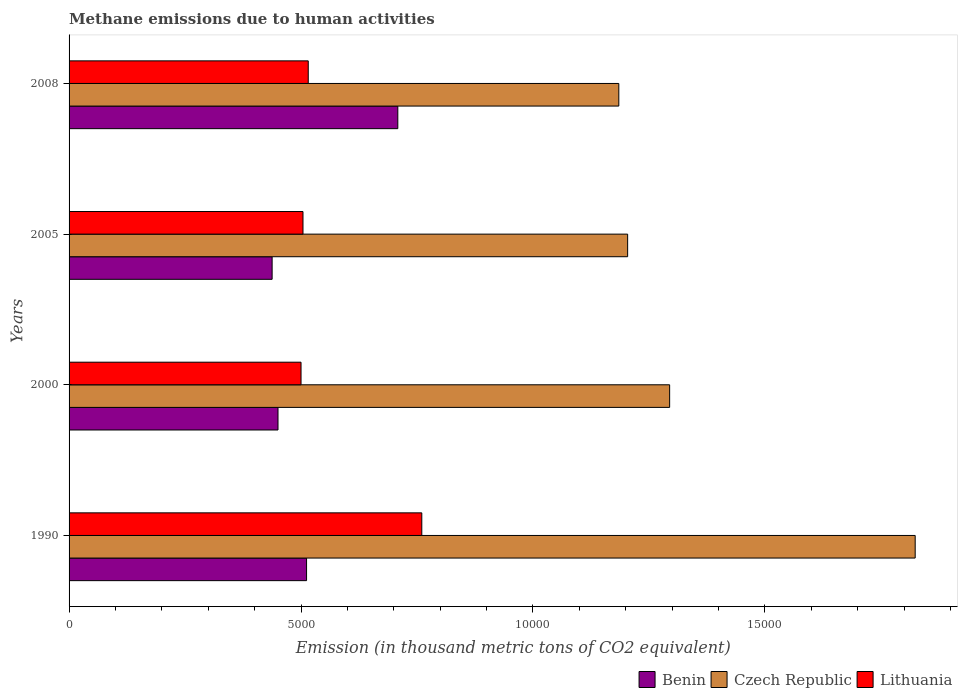How many bars are there on the 3rd tick from the top?
Your response must be concise. 3. What is the label of the 3rd group of bars from the top?
Your answer should be very brief. 2000. What is the amount of methane emitted in Benin in 2008?
Keep it short and to the point. 7086.6. Across all years, what is the maximum amount of methane emitted in Benin?
Your answer should be very brief. 7086.6. Across all years, what is the minimum amount of methane emitted in Czech Republic?
Your answer should be compact. 1.19e+04. In which year was the amount of methane emitted in Lithuania maximum?
Keep it short and to the point. 1990. What is the total amount of methane emitted in Czech Republic in the graph?
Offer a very short reply. 5.51e+04. What is the difference between the amount of methane emitted in Benin in 2000 and that in 2008?
Provide a succinct answer. -2582.8. What is the difference between the amount of methane emitted in Lithuania in 2005 and the amount of methane emitted in Czech Republic in 2008?
Provide a short and direct response. -6808.2. What is the average amount of methane emitted in Benin per year?
Keep it short and to the point. 5271.8. In the year 2000, what is the difference between the amount of methane emitted in Benin and amount of methane emitted in Lithuania?
Ensure brevity in your answer.  -496.4. What is the ratio of the amount of methane emitted in Benin in 2005 to that in 2008?
Give a very brief answer. 0.62. Is the amount of methane emitted in Benin in 2000 less than that in 2008?
Provide a succinct answer. Yes. What is the difference between the highest and the second highest amount of methane emitted in Benin?
Your answer should be very brief. 1967.1. What is the difference between the highest and the lowest amount of methane emitted in Czech Republic?
Your answer should be compact. 6388.9. In how many years, is the amount of methane emitted in Lithuania greater than the average amount of methane emitted in Lithuania taken over all years?
Provide a succinct answer. 1. Is the sum of the amount of methane emitted in Benin in 1990 and 2008 greater than the maximum amount of methane emitted in Lithuania across all years?
Give a very brief answer. Yes. What does the 2nd bar from the top in 1990 represents?
Offer a very short reply. Czech Republic. What does the 3rd bar from the bottom in 2000 represents?
Offer a very short reply. Lithuania. Is it the case that in every year, the sum of the amount of methane emitted in Czech Republic and amount of methane emitted in Benin is greater than the amount of methane emitted in Lithuania?
Make the answer very short. Yes. How many years are there in the graph?
Your answer should be compact. 4. What is the difference between two consecutive major ticks on the X-axis?
Offer a very short reply. 5000. Does the graph contain any zero values?
Ensure brevity in your answer.  No. Does the graph contain grids?
Keep it short and to the point. No. Where does the legend appear in the graph?
Make the answer very short. Bottom right. How many legend labels are there?
Your response must be concise. 3. How are the legend labels stacked?
Your response must be concise. Horizontal. What is the title of the graph?
Give a very brief answer. Methane emissions due to human activities. Does "Eritrea" appear as one of the legend labels in the graph?
Your response must be concise. No. What is the label or title of the X-axis?
Your response must be concise. Emission (in thousand metric tons of CO2 equivalent). What is the label or title of the Y-axis?
Give a very brief answer. Years. What is the Emission (in thousand metric tons of CO2 equivalent) of Benin in 1990?
Give a very brief answer. 5119.5. What is the Emission (in thousand metric tons of CO2 equivalent) of Czech Republic in 1990?
Your answer should be very brief. 1.82e+04. What is the Emission (in thousand metric tons of CO2 equivalent) of Lithuania in 1990?
Make the answer very short. 7603.6. What is the Emission (in thousand metric tons of CO2 equivalent) in Benin in 2000?
Offer a very short reply. 4503.8. What is the Emission (in thousand metric tons of CO2 equivalent) in Czech Republic in 2000?
Provide a short and direct response. 1.29e+04. What is the Emission (in thousand metric tons of CO2 equivalent) in Lithuania in 2000?
Give a very brief answer. 5000.2. What is the Emission (in thousand metric tons of CO2 equivalent) in Benin in 2005?
Give a very brief answer. 4377.3. What is the Emission (in thousand metric tons of CO2 equivalent) in Czech Republic in 2005?
Your answer should be compact. 1.20e+04. What is the Emission (in thousand metric tons of CO2 equivalent) in Lithuania in 2005?
Provide a short and direct response. 5042.2. What is the Emission (in thousand metric tons of CO2 equivalent) in Benin in 2008?
Keep it short and to the point. 7086.6. What is the Emission (in thousand metric tons of CO2 equivalent) in Czech Republic in 2008?
Your answer should be very brief. 1.19e+04. What is the Emission (in thousand metric tons of CO2 equivalent) of Lithuania in 2008?
Ensure brevity in your answer.  5155.8. Across all years, what is the maximum Emission (in thousand metric tons of CO2 equivalent) in Benin?
Your answer should be very brief. 7086.6. Across all years, what is the maximum Emission (in thousand metric tons of CO2 equivalent) in Czech Republic?
Keep it short and to the point. 1.82e+04. Across all years, what is the maximum Emission (in thousand metric tons of CO2 equivalent) in Lithuania?
Give a very brief answer. 7603.6. Across all years, what is the minimum Emission (in thousand metric tons of CO2 equivalent) in Benin?
Your response must be concise. 4377.3. Across all years, what is the minimum Emission (in thousand metric tons of CO2 equivalent) in Czech Republic?
Provide a succinct answer. 1.19e+04. Across all years, what is the minimum Emission (in thousand metric tons of CO2 equivalent) in Lithuania?
Your answer should be very brief. 5000.2. What is the total Emission (in thousand metric tons of CO2 equivalent) in Benin in the graph?
Offer a very short reply. 2.11e+04. What is the total Emission (in thousand metric tons of CO2 equivalent) in Czech Republic in the graph?
Your answer should be very brief. 5.51e+04. What is the total Emission (in thousand metric tons of CO2 equivalent) in Lithuania in the graph?
Your answer should be compact. 2.28e+04. What is the difference between the Emission (in thousand metric tons of CO2 equivalent) of Benin in 1990 and that in 2000?
Keep it short and to the point. 615.7. What is the difference between the Emission (in thousand metric tons of CO2 equivalent) of Czech Republic in 1990 and that in 2000?
Give a very brief answer. 5293.1. What is the difference between the Emission (in thousand metric tons of CO2 equivalent) in Lithuania in 1990 and that in 2000?
Provide a succinct answer. 2603.4. What is the difference between the Emission (in thousand metric tons of CO2 equivalent) of Benin in 1990 and that in 2005?
Keep it short and to the point. 742.2. What is the difference between the Emission (in thousand metric tons of CO2 equivalent) in Czech Republic in 1990 and that in 2005?
Provide a succinct answer. 6198.5. What is the difference between the Emission (in thousand metric tons of CO2 equivalent) in Lithuania in 1990 and that in 2005?
Your answer should be very brief. 2561.4. What is the difference between the Emission (in thousand metric tons of CO2 equivalent) in Benin in 1990 and that in 2008?
Your answer should be very brief. -1967.1. What is the difference between the Emission (in thousand metric tons of CO2 equivalent) of Czech Republic in 1990 and that in 2008?
Give a very brief answer. 6388.9. What is the difference between the Emission (in thousand metric tons of CO2 equivalent) of Lithuania in 1990 and that in 2008?
Your answer should be compact. 2447.8. What is the difference between the Emission (in thousand metric tons of CO2 equivalent) in Benin in 2000 and that in 2005?
Your response must be concise. 126.5. What is the difference between the Emission (in thousand metric tons of CO2 equivalent) in Czech Republic in 2000 and that in 2005?
Offer a terse response. 905.4. What is the difference between the Emission (in thousand metric tons of CO2 equivalent) in Lithuania in 2000 and that in 2005?
Keep it short and to the point. -42. What is the difference between the Emission (in thousand metric tons of CO2 equivalent) in Benin in 2000 and that in 2008?
Keep it short and to the point. -2582.8. What is the difference between the Emission (in thousand metric tons of CO2 equivalent) of Czech Republic in 2000 and that in 2008?
Ensure brevity in your answer.  1095.8. What is the difference between the Emission (in thousand metric tons of CO2 equivalent) in Lithuania in 2000 and that in 2008?
Your answer should be compact. -155.6. What is the difference between the Emission (in thousand metric tons of CO2 equivalent) in Benin in 2005 and that in 2008?
Your answer should be very brief. -2709.3. What is the difference between the Emission (in thousand metric tons of CO2 equivalent) in Czech Republic in 2005 and that in 2008?
Your answer should be very brief. 190.4. What is the difference between the Emission (in thousand metric tons of CO2 equivalent) of Lithuania in 2005 and that in 2008?
Provide a succinct answer. -113.6. What is the difference between the Emission (in thousand metric tons of CO2 equivalent) in Benin in 1990 and the Emission (in thousand metric tons of CO2 equivalent) in Czech Republic in 2000?
Offer a terse response. -7826.7. What is the difference between the Emission (in thousand metric tons of CO2 equivalent) of Benin in 1990 and the Emission (in thousand metric tons of CO2 equivalent) of Lithuania in 2000?
Your response must be concise. 119.3. What is the difference between the Emission (in thousand metric tons of CO2 equivalent) in Czech Republic in 1990 and the Emission (in thousand metric tons of CO2 equivalent) in Lithuania in 2000?
Your answer should be very brief. 1.32e+04. What is the difference between the Emission (in thousand metric tons of CO2 equivalent) in Benin in 1990 and the Emission (in thousand metric tons of CO2 equivalent) in Czech Republic in 2005?
Offer a very short reply. -6921.3. What is the difference between the Emission (in thousand metric tons of CO2 equivalent) in Benin in 1990 and the Emission (in thousand metric tons of CO2 equivalent) in Lithuania in 2005?
Offer a terse response. 77.3. What is the difference between the Emission (in thousand metric tons of CO2 equivalent) in Czech Republic in 1990 and the Emission (in thousand metric tons of CO2 equivalent) in Lithuania in 2005?
Offer a terse response. 1.32e+04. What is the difference between the Emission (in thousand metric tons of CO2 equivalent) of Benin in 1990 and the Emission (in thousand metric tons of CO2 equivalent) of Czech Republic in 2008?
Keep it short and to the point. -6730.9. What is the difference between the Emission (in thousand metric tons of CO2 equivalent) in Benin in 1990 and the Emission (in thousand metric tons of CO2 equivalent) in Lithuania in 2008?
Your response must be concise. -36.3. What is the difference between the Emission (in thousand metric tons of CO2 equivalent) in Czech Republic in 1990 and the Emission (in thousand metric tons of CO2 equivalent) in Lithuania in 2008?
Your answer should be compact. 1.31e+04. What is the difference between the Emission (in thousand metric tons of CO2 equivalent) in Benin in 2000 and the Emission (in thousand metric tons of CO2 equivalent) in Czech Republic in 2005?
Give a very brief answer. -7537. What is the difference between the Emission (in thousand metric tons of CO2 equivalent) of Benin in 2000 and the Emission (in thousand metric tons of CO2 equivalent) of Lithuania in 2005?
Give a very brief answer. -538.4. What is the difference between the Emission (in thousand metric tons of CO2 equivalent) of Czech Republic in 2000 and the Emission (in thousand metric tons of CO2 equivalent) of Lithuania in 2005?
Provide a succinct answer. 7904. What is the difference between the Emission (in thousand metric tons of CO2 equivalent) of Benin in 2000 and the Emission (in thousand metric tons of CO2 equivalent) of Czech Republic in 2008?
Offer a very short reply. -7346.6. What is the difference between the Emission (in thousand metric tons of CO2 equivalent) in Benin in 2000 and the Emission (in thousand metric tons of CO2 equivalent) in Lithuania in 2008?
Your answer should be compact. -652. What is the difference between the Emission (in thousand metric tons of CO2 equivalent) in Czech Republic in 2000 and the Emission (in thousand metric tons of CO2 equivalent) in Lithuania in 2008?
Offer a very short reply. 7790.4. What is the difference between the Emission (in thousand metric tons of CO2 equivalent) of Benin in 2005 and the Emission (in thousand metric tons of CO2 equivalent) of Czech Republic in 2008?
Your response must be concise. -7473.1. What is the difference between the Emission (in thousand metric tons of CO2 equivalent) in Benin in 2005 and the Emission (in thousand metric tons of CO2 equivalent) in Lithuania in 2008?
Offer a terse response. -778.5. What is the difference between the Emission (in thousand metric tons of CO2 equivalent) in Czech Republic in 2005 and the Emission (in thousand metric tons of CO2 equivalent) in Lithuania in 2008?
Provide a succinct answer. 6885. What is the average Emission (in thousand metric tons of CO2 equivalent) in Benin per year?
Offer a very short reply. 5271.8. What is the average Emission (in thousand metric tons of CO2 equivalent) in Czech Republic per year?
Offer a very short reply. 1.38e+04. What is the average Emission (in thousand metric tons of CO2 equivalent) of Lithuania per year?
Ensure brevity in your answer.  5700.45. In the year 1990, what is the difference between the Emission (in thousand metric tons of CO2 equivalent) in Benin and Emission (in thousand metric tons of CO2 equivalent) in Czech Republic?
Provide a succinct answer. -1.31e+04. In the year 1990, what is the difference between the Emission (in thousand metric tons of CO2 equivalent) of Benin and Emission (in thousand metric tons of CO2 equivalent) of Lithuania?
Provide a succinct answer. -2484.1. In the year 1990, what is the difference between the Emission (in thousand metric tons of CO2 equivalent) of Czech Republic and Emission (in thousand metric tons of CO2 equivalent) of Lithuania?
Your answer should be compact. 1.06e+04. In the year 2000, what is the difference between the Emission (in thousand metric tons of CO2 equivalent) in Benin and Emission (in thousand metric tons of CO2 equivalent) in Czech Republic?
Your answer should be compact. -8442.4. In the year 2000, what is the difference between the Emission (in thousand metric tons of CO2 equivalent) of Benin and Emission (in thousand metric tons of CO2 equivalent) of Lithuania?
Make the answer very short. -496.4. In the year 2000, what is the difference between the Emission (in thousand metric tons of CO2 equivalent) in Czech Republic and Emission (in thousand metric tons of CO2 equivalent) in Lithuania?
Make the answer very short. 7946. In the year 2005, what is the difference between the Emission (in thousand metric tons of CO2 equivalent) of Benin and Emission (in thousand metric tons of CO2 equivalent) of Czech Republic?
Provide a succinct answer. -7663.5. In the year 2005, what is the difference between the Emission (in thousand metric tons of CO2 equivalent) in Benin and Emission (in thousand metric tons of CO2 equivalent) in Lithuania?
Give a very brief answer. -664.9. In the year 2005, what is the difference between the Emission (in thousand metric tons of CO2 equivalent) in Czech Republic and Emission (in thousand metric tons of CO2 equivalent) in Lithuania?
Give a very brief answer. 6998.6. In the year 2008, what is the difference between the Emission (in thousand metric tons of CO2 equivalent) in Benin and Emission (in thousand metric tons of CO2 equivalent) in Czech Republic?
Your answer should be very brief. -4763.8. In the year 2008, what is the difference between the Emission (in thousand metric tons of CO2 equivalent) of Benin and Emission (in thousand metric tons of CO2 equivalent) of Lithuania?
Provide a succinct answer. 1930.8. In the year 2008, what is the difference between the Emission (in thousand metric tons of CO2 equivalent) of Czech Republic and Emission (in thousand metric tons of CO2 equivalent) of Lithuania?
Offer a very short reply. 6694.6. What is the ratio of the Emission (in thousand metric tons of CO2 equivalent) in Benin in 1990 to that in 2000?
Give a very brief answer. 1.14. What is the ratio of the Emission (in thousand metric tons of CO2 equivalent) in Czech Republic in 1990 to that in 2000?
Your response must be concise. 1.41. What is the ratio of the Emission (in thousand metric tons of CO2 equivalent) of Lithuania in 1990 to that in 2000?
Provide a succinct answer. 1.52. What is the ratio of the Emission (in thousand metric tons of CO2 equivalent) in Benin in 1990 to that in 2005?
Make the answer very short. 1.17. What is the ratio of the Emission (in thousand metric tons of CO2 equivalent) in Czech Republic in 1990 to that in 2005?
Your answer should be very brief. 1.51. What is the ratio of the Emission (in thousand metric tons of CO2 equivalent) of Lithuania in 1990 to that in 2005?
Provide a short and direct response. 1.51. What is the ratio of the Emission (in thousand metric tons of CO2 equivalent) in Benin in 1990 to that in 2008?
Make the answer very short. 0.72. What is the ratio of the Emission (in thousand metric tons of CO2 equivalent) of Czech Republic in 1990 to that in 2008?
Your answer should be compact. 1.54. What is the ratio of the Emission (in thousand metric tons of CO2 equivalent) in Lithuania in 1990 to that in 2008?
Your answer should be very brief. 1.47. What is the ratio of the Emission (in thousand metric tons of CO2 equivalent) in Benin in 2000 to that in 2005?
Your answer should be very brief. 1.03. What is the ratio of the Emission (in thousand metric tons of CO2 equivalent) of Czech Republic in 2000 to that in 2005?
Your answer should be very brief. 1.08. What is the ratio of the Emission (in thousand metric tons of CO2 equivalent) in Lithuania in 2000 to that in 2005?
Make the answer very short. 0.99. What is the ratio of the Emission (in thousand metric tons of CO2 equivalent) of Benin in 2000 to that in 2008?
Keep it short and to the point. 0.64. What is the ratio of the Emission (in thousand metric tons of CO2 equivalent) in Czech Republic in 2000 to that in 2008?
Ensure brevity in your answer.  1.09. What is the ratio of the Emission (in thousand metric tons of CO2 equivalent) in Lithuania in 2000 to that in 2008?
Your answer should be very brief. 0.97. What is the ratio of the Emission (in thousand metric tons of CO2 equivalent) of Benin in 2005 to that in 2008?
Offer a very short reply. 0.62. What is the ratio of the Emission (in thousand metric tons of CO2 equivalent) of Czech Republic in 2005 to that in 2008?
Provide a short and direct response. 1.02. What is the difference between the highest and the second highest Emission (in thousand metric tons of CO2 equivalent) of Benin?
Provide a succinct answer. 1967.1. What is the difference between the highest and the second highest Emission (in thousand metric tons of CO2 equivalent) in Czech Republic?
Keep it short and to the point. 5293.1. What is the difference between the highest and the second highest Emission (in thousand metric tons of CO2 equivalent) in Lithuania?
Keep it short and to the point. 2447.8. What is the difference between the highest and the lowest Emission (in thousand metric tons of CO2 equivalent) in Benin?
Keep it short and to the point. 2709.3. What is the difference between the highest and the lowest Emission (in thousand metric tons of CO2 equivalent) in Czech Republic?
Your answer should be compact. 6388.9. What is the difference between the highest and the lowest Emission (in thousand metric tons of CO2 equivalent) of Lithuania?
Your answer should be compact. 2603.4. 